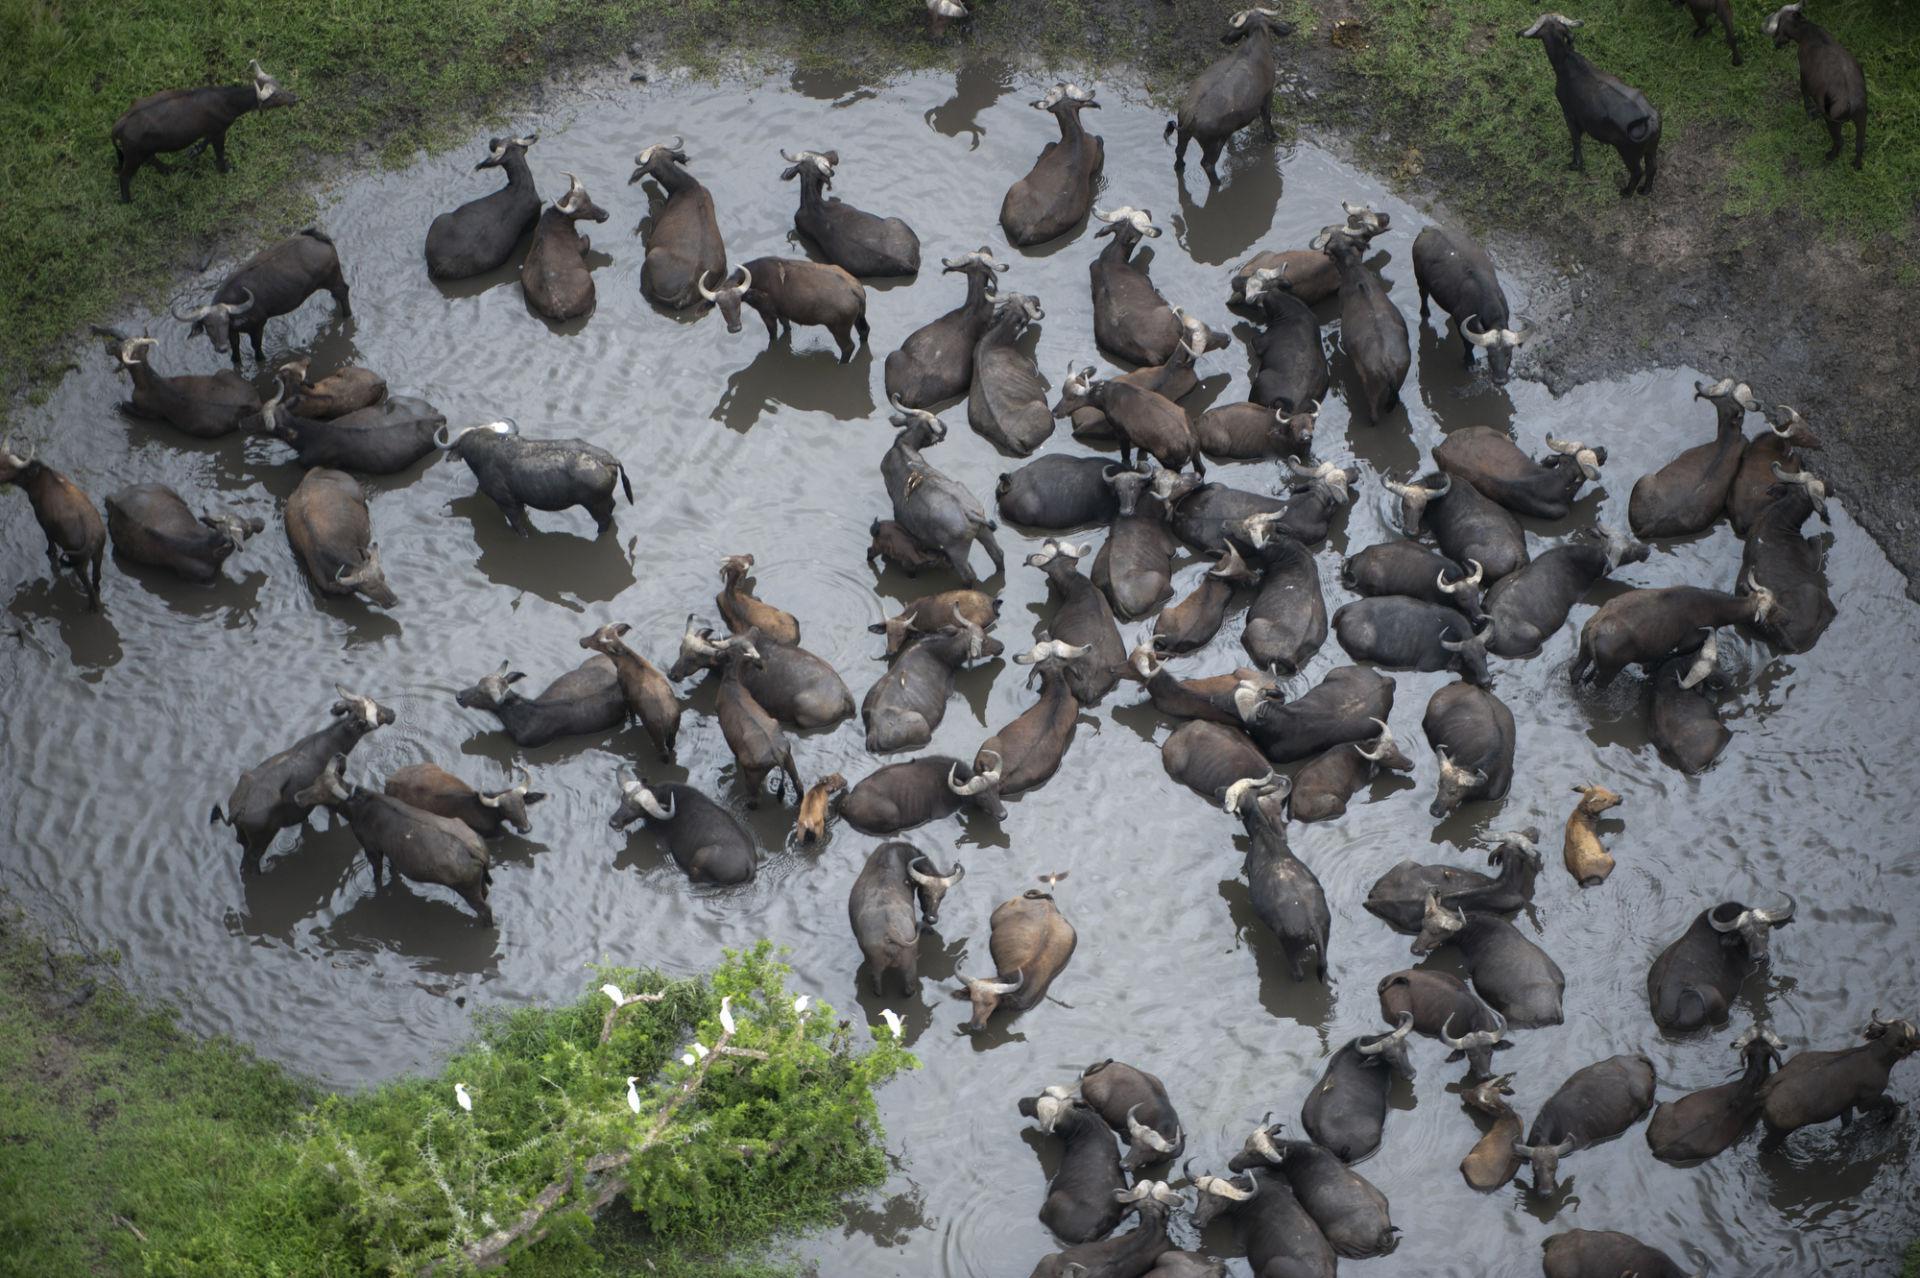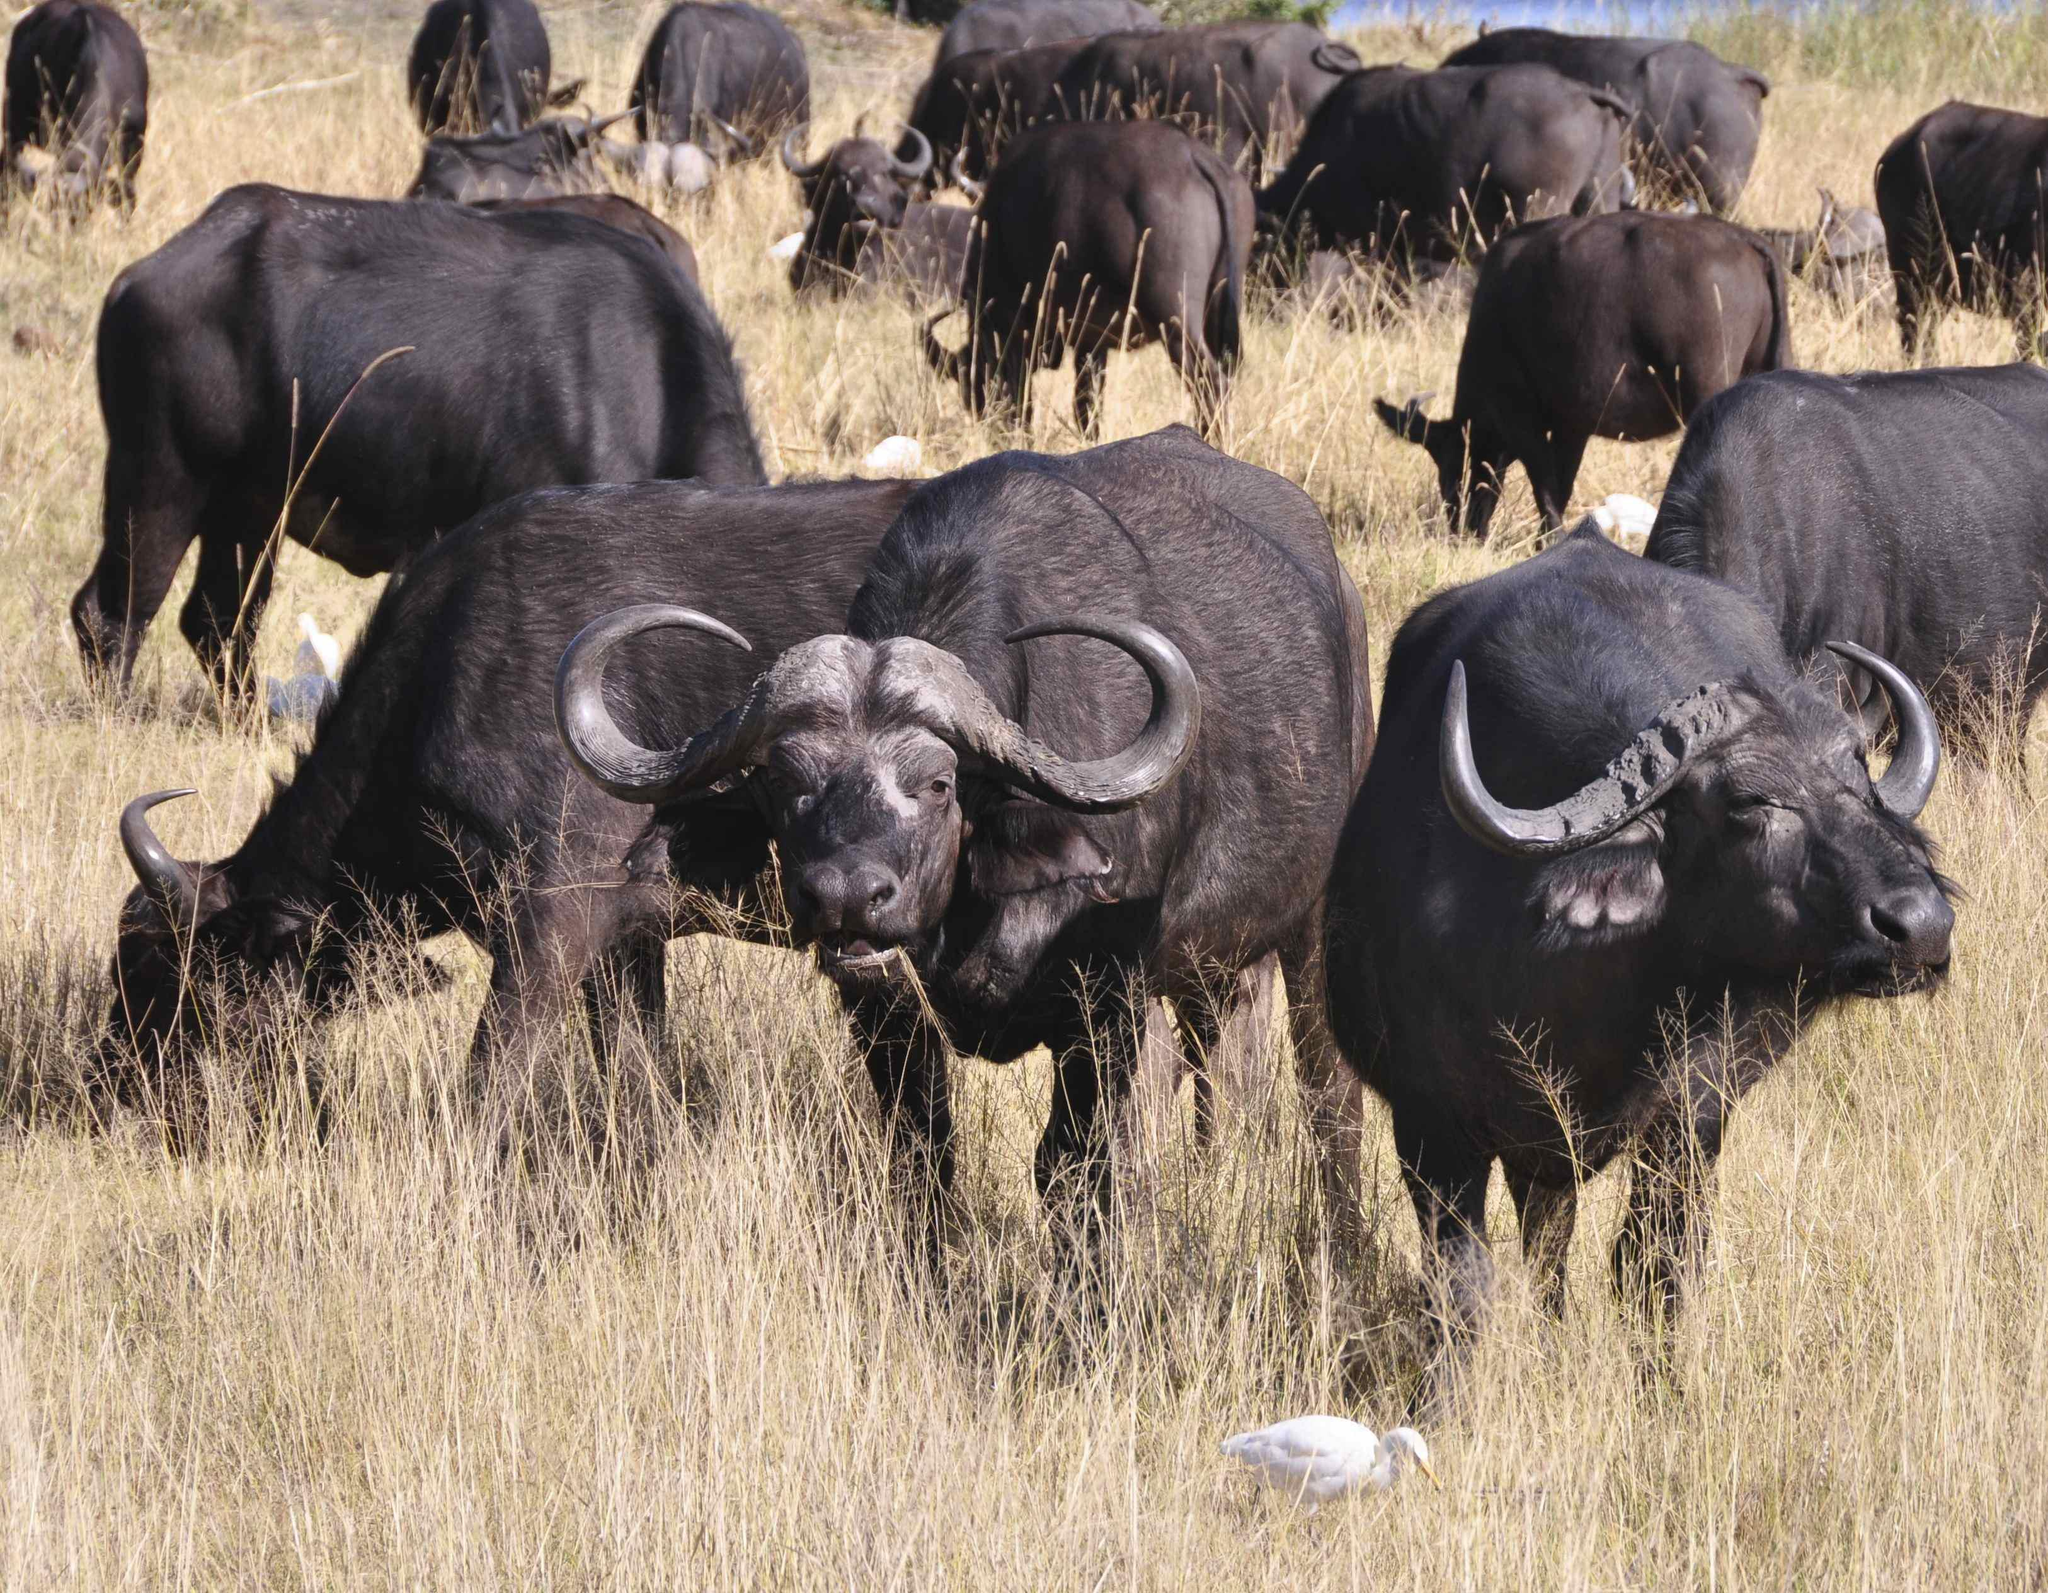The first image is the image on the left, the second image is the image on the right. Evaluate the accuracy of this statement regarding the images: "there are animals in the water in the image on the right side". Is it true? Answer yes or no. No. The first image is the image on the left, the second image is the image on the right. Considering the images on both sides, is "All animals in the right image are on land." valid? Answer yes or no. Yes. 